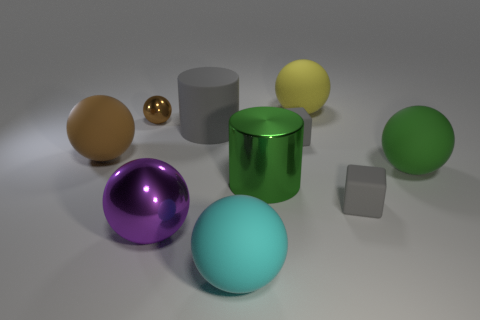What is the shape of the large object that is the same color as the tiny metallic ball?
Provide a short and direct response. Sphere. Is there a large green object that has the same shape as the large gray rubber object?
Your response must be concise. Yes. There is a tiny object on the left side of the cyan rubber thing; is its shape the same as the large green object right of the big yellow rubber sphere?
Offer a very short reply. Yes. Is there a green matte cylinder of the same size as the purple metallic thing?
Keep it short and to the point. No. Is the number of large matte balls that are behind the brown metallic thing the same as the number of purple objects behind the big yellow rubber object?
Give a very brief answer. No. Is the material of the ball in front of the purple sphere the same as the small object on the left side of the large shiny sphere?
Provide a succinct answer. No. What is the small brown thing made of?
Your answer should be very brief. Metal. How many other objects are there of the same color as the small metallic sphere?
Your answer should be very brief. 1. How many yellow matte blocks are there?
Provide a succinct answer. 0. There is a green thing left of the big sphere that is behind the brown matte object; what is it made of?
Keep it short and to the point. Metal. 